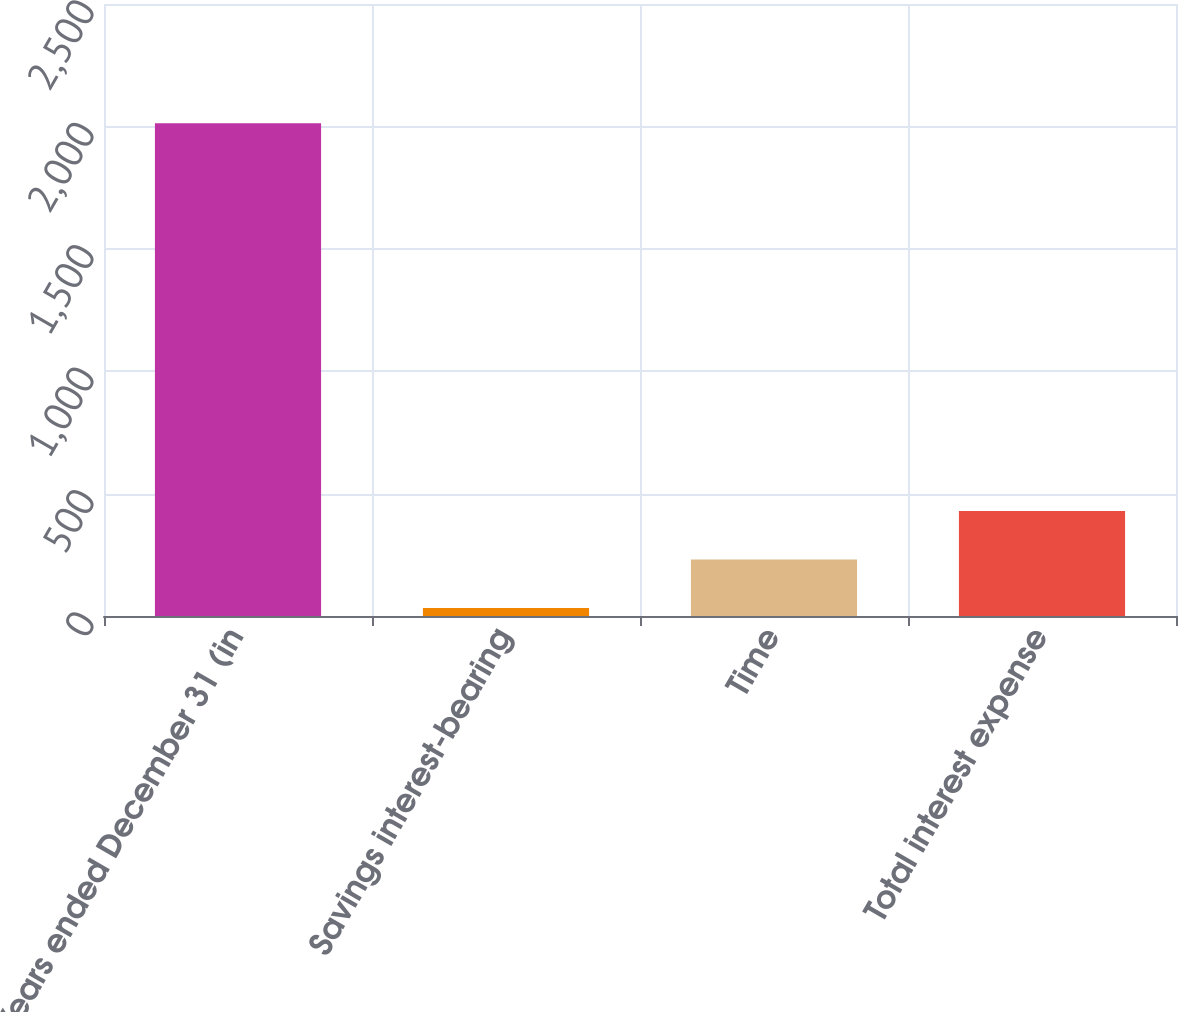Convert chart to OTSL. <chart><loc_0><loc_0><loc_500><loc_500><bar_chart><fcel>Years ended December 31 (in<fcel>Savings interest-bearing<fcel>Time<fcel>Total interest expense<nl><fcel>2013<fcel>33<fcel>231<fcel>429<nl></chart> 